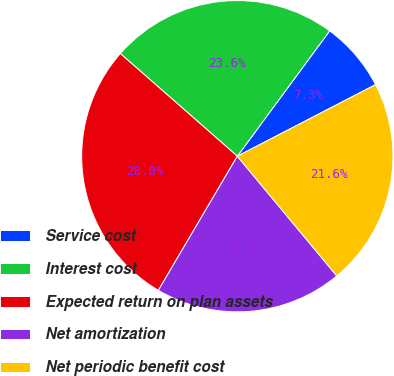Convert chart to OTSL. <chart><loc_0><loc_0><loc_500><loc_500><pie_chart><fcel>Service cost<fcel>Interest cost<fcel>Expected return on plan assets<fcel>Net amortization<fcel>Net periodic benefit cost<nl><fcel>7.29%<fcel>23.64%<fcel>27.99%<fcel>19.5%<fcel>21.57%<nl></chart> 